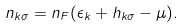<formula> <loc_0><loc_0><loc_500><loc_500>n _ { { k } \sigma } = n _ { F } ( \epsilon _ { k } + h _ { { k } \sigma } - \mu ) .</formula> 